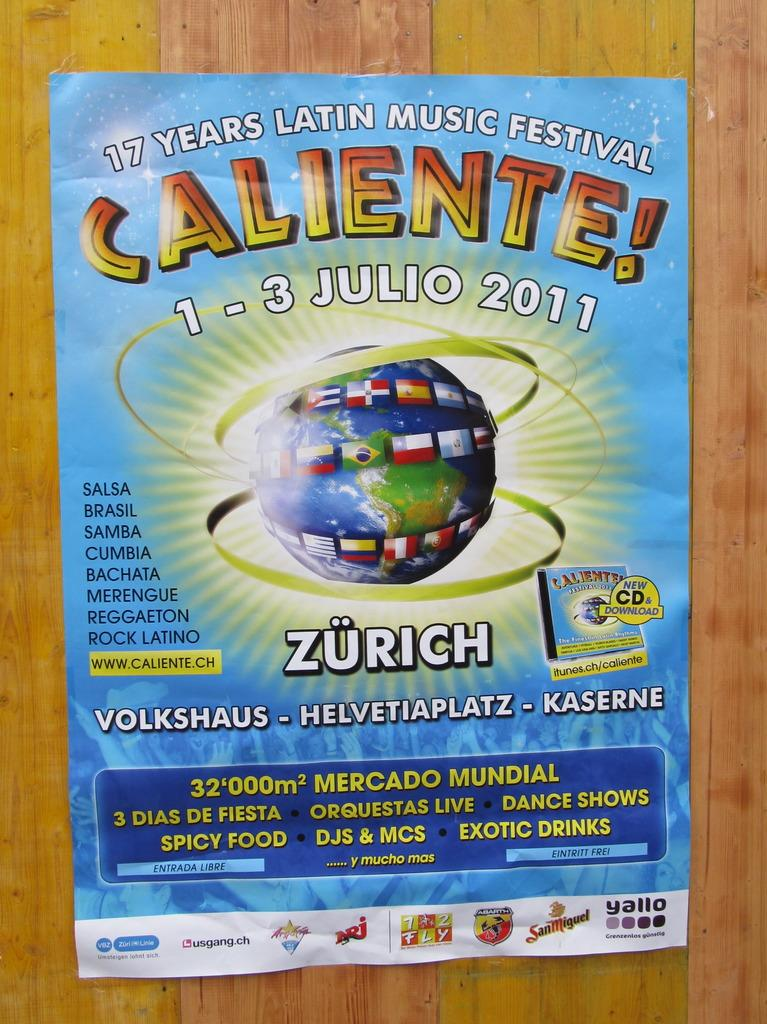<image>
Provide a brief description of the given image. 1-3 Julio is the date of the Caliente festival. 